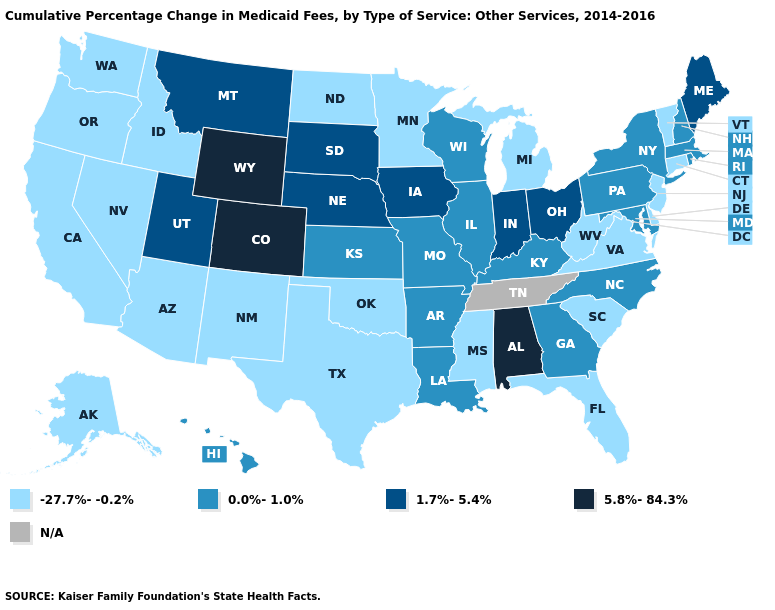What is the lowest value in states that border Pennsylvania?
Concise answer only. -27.7%--0.2%. How many symbols are there in the legend?
Keep it brief. 5. What is the value of Oklahoma?
Write a very short answer. -27.7%--0.2%. What is the value of Montana?
Concise answer only. 1.7%-5.4%. Does Nebraska have the lowest value in the USA?
Write a very short answer. No. Name the states that have a value in the range -27.7%--0.2%?
Write a very short answer. Alaska, Arizona, California, Connecticut, Delaware, Florida, Idaho, Michigan, Minnesota, Mississippi, Nevada, New Jersey, New Mexico, North Dakota, Oklahoma, Oregon, South Carolina, Texas, Vermont, Virginia, Washington, West Virginia. Which states have the highest value in the USA?
Be succinct. Alabama, Colorado, Wyoming. What is the highest value in the USA?
Answer briefly. 5.8%-84.3%. Name the states that have a value in the range N/A?
Give a very brief answer. Tennessee. What is the value of Colorado?
Answer briefly. 5.8%-84.3%. What is the value of Maryland?
Short answer required. 0.0%-1.0%. What is the value of Hawaii?
Write a very short answer. 0.0%-1.0%. Does the first symbol in the legend represent the smallest category?
Answer briefly. Yes. What is the value of New Jersey?
Answer briefly. -27.7%--0.2%. 